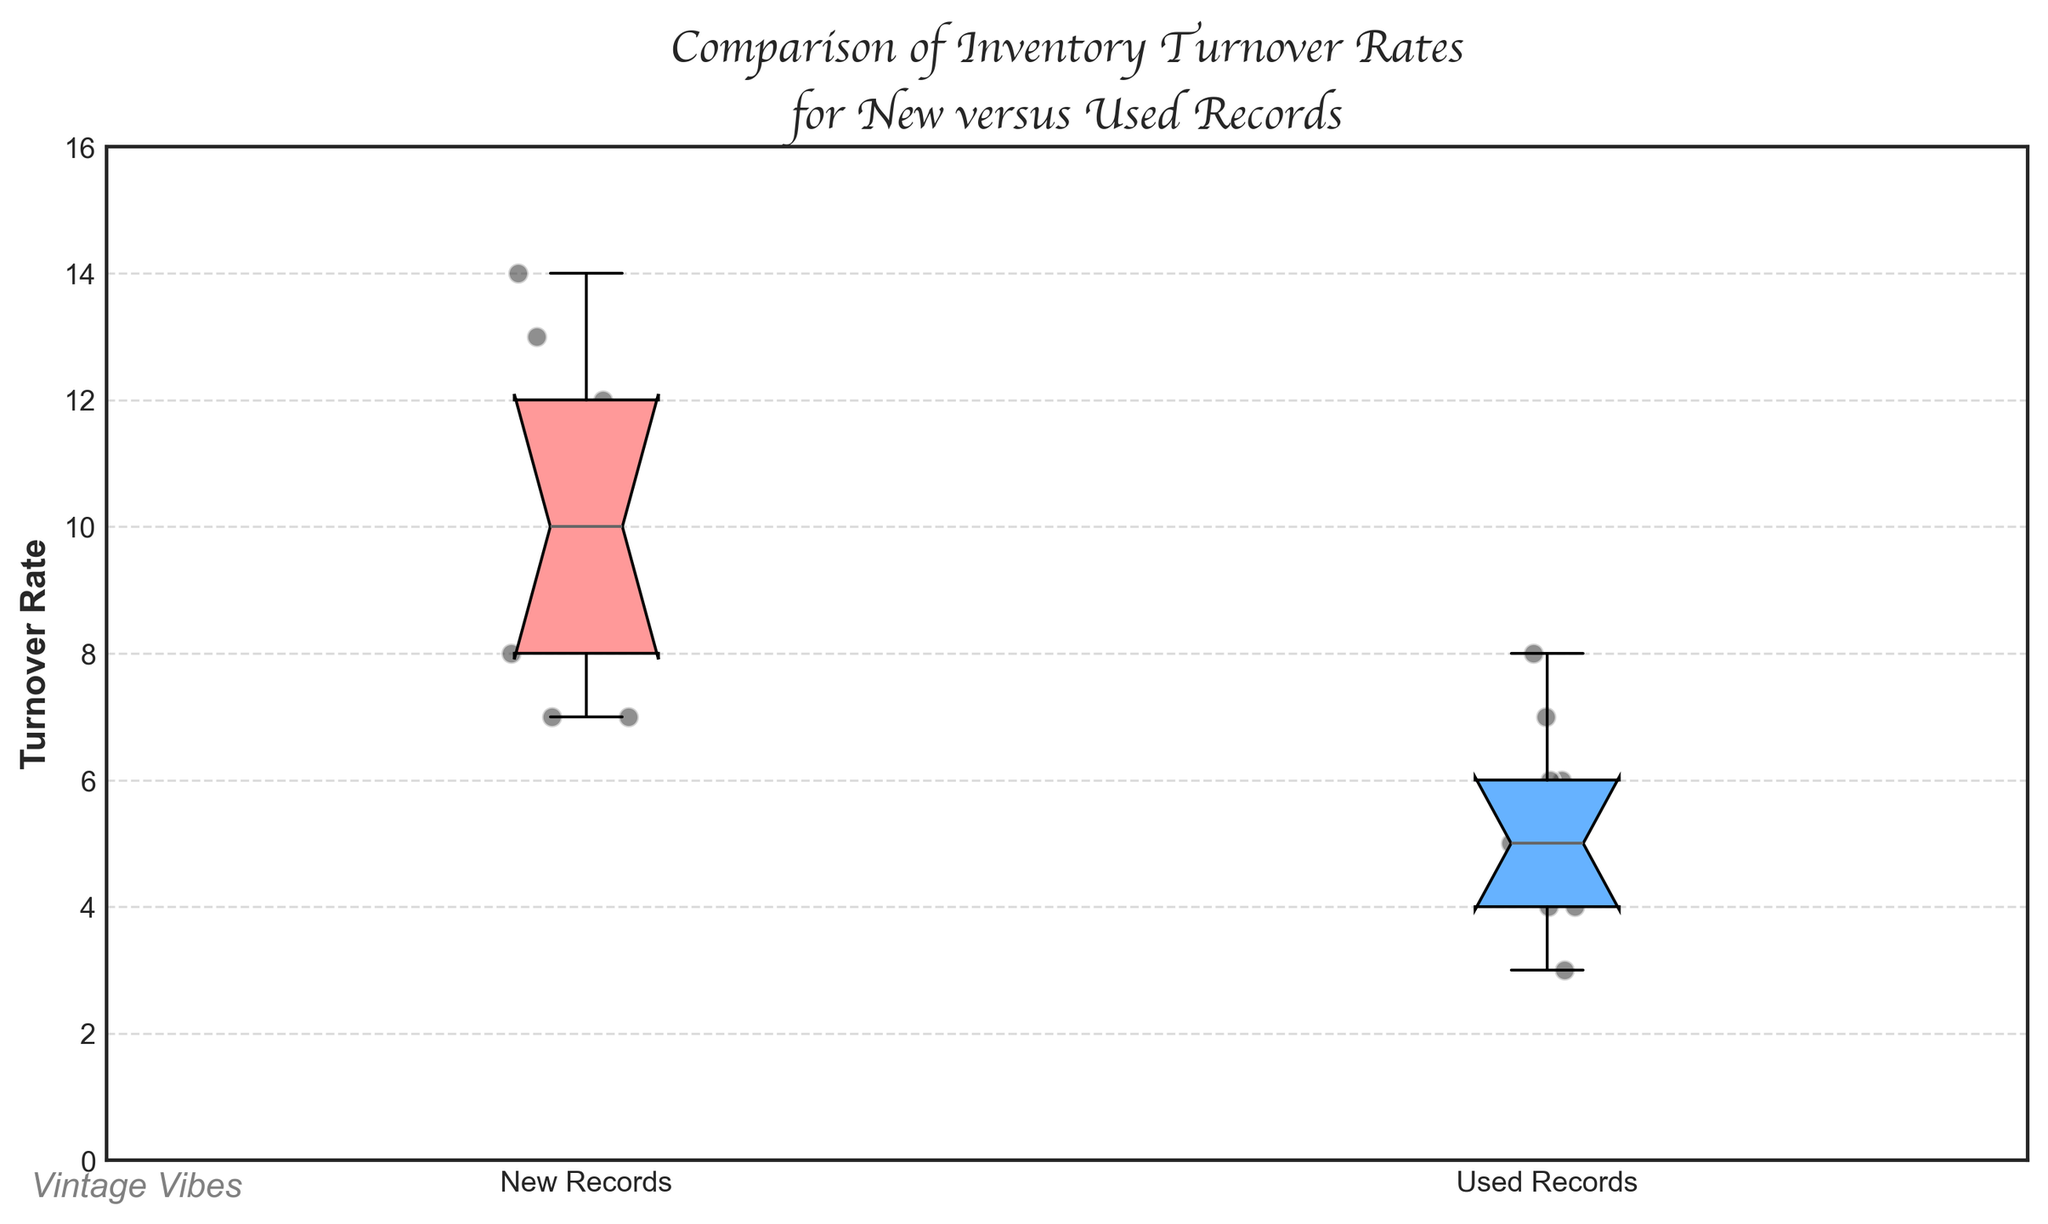What is the title of the figure? The title is usually written at the top of the figure. Here, it states "Comparison of Inventory Turnover Rates for New versus Used Records."
Answer: Comparison of Inventory Turnover Rates for New versus Used Records What do the colors of the boxes represent? The boxes are different colors, with one representing 'New Records' and the other 'Used Records.' The pinkish box represents 'New Records,' and the bluish box represents 'Used Records.'
Answer: 'New Records' and 'Used Records' What is the median turnover rate for new records? The median is shown by the line inside the notch of the box for new records. It appears slightly above 11.
Answer: Approximately 12 Which group has a higher median turnover rate, new or used records? The medians are represented by the lines within the boxes. The line in the box for new records is higher than that for used records.
Answer: New records What range of turnover rates is shown for new records? The range is defined by the minimum and maximum values shown by the whiskers of the box plot. For new records, it ranges from slightly below 7 to just above 14.
Answer: Approximately 7 to 14 How does the interquartile range (IQR) for new records compare to that for used records? The IQR is shown by the height of the box. For new records, the box is taller than for used records, indicating a larger IQR.
Answer: The IQR for new records is larger than that for used records What can you infer about the variability in turnover rates between new and used records? The width of the notched boxes and the lengths of the whiskers provide information about variability. New records show more variability as the box and whiskers are longer compared to used records.
Answer: New records have more variability Which group has the lower whisker nearer to zero, new or used records? The lower whisker for used records reaches values closer to zero compared to new records.
Answer: Used records Are there any noticeable outliers in the data? Outliers would be points outside the whiskers. In this case, there are no points outside the whiskers for either new or used records.
Answer: No What is the approximate interquartile range (IQR) for used records? The IQR is the height of the box between the 25th and 75th percentiles. For used records, this span is from about 4 to just below 7.
Answer: Approximately from 4 to 7 